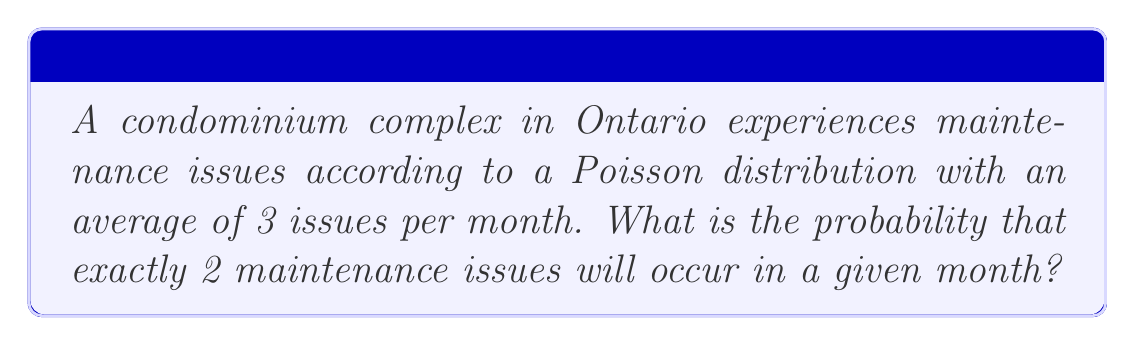Help me with this question. To solve this problem, we'll use the Poisson probability formula:

$$P(X = k) = \frac{e^{-\lambda} \lambda^k}{k!}$$

Where:
$\lambda$ = average number of events in the given time period
$k$ = number of events we're calculating the probability for
$e$ = Euler's number (approximately 2.71828)

Given:
$\lambda = 3$ (average of 3 issues per month)
$k = 2$ (we're calculating the probability of exactly 2 issues)

Step 1: Substitute the values into the formula:
$$P(X = 2) = \frac{e^{-3} 3^2}{2!}$$

Step 2: Simplify the numerator:
$$P(X = 2) = \frac{e^{-3} \cdot 9}{2!}$$

Step 3: Calculate $e^{-3}$ (using a calculator):
$$e^{-3} \approx 0.0497871$$

Step 4: Substitute this value and calculate:
$$P(X = 2) = \frac{0.0497871 \cdot 9}{2} \approx 0.2240$$

Therefore, the probability of exactly 2 maintenance issues occurring in a given month is approximately 0.2240 or 22.40%.
Answer: $0.2240$ or $22.40\%$ 